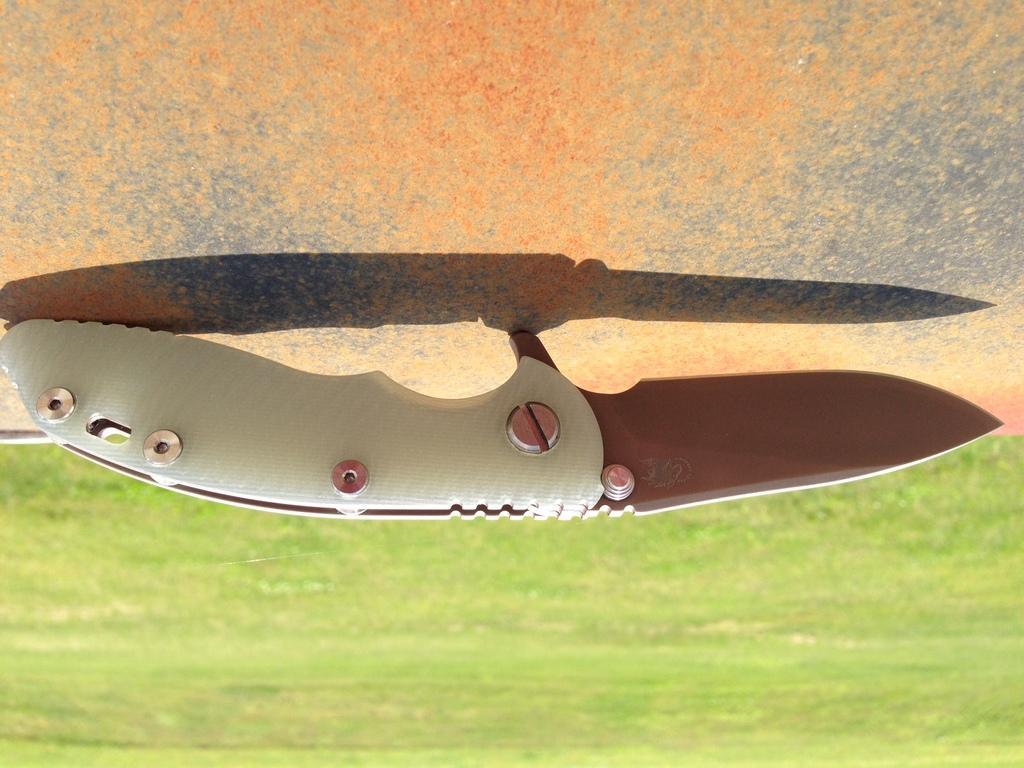Please provide a concise description of this image. In the image in the center we can see one knife,which is in white color. In the bottom of the image,we can see grass. 